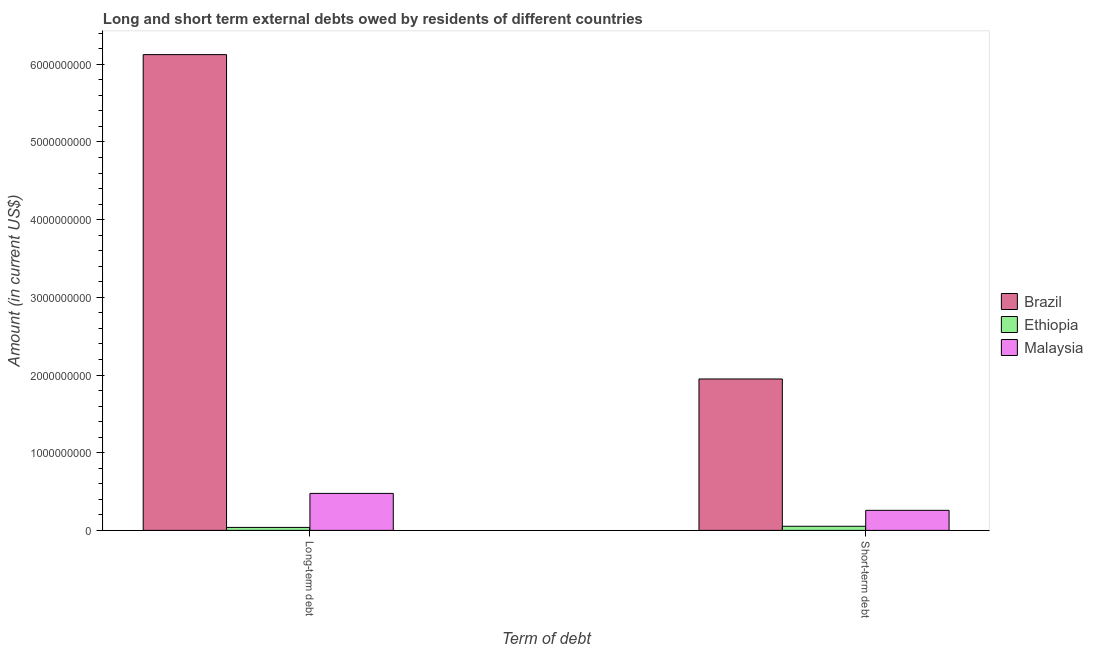How many groups of bars are there?
Offer a very short reply. 2. Are the number of bars on each tick of the X-axis equal?
Keep it short and to the point. Yes. How many bars are there on the 1st tick from the left?
Provide a short and direct response. 3. What is the label of the 2nd group of bars from the left?
Keep it short and to the point. Short-term debt. What is the short-term debts owed by residents in Ethiopia?
Make the answer very short. 5.30e+07. Across all countries, what is the maximum long-term debts owed by residents?
Your answer should be compact. 6.12e+09. Across all countries, what is the minimum long-term debts owed by residents?
Make the answer very short. 3.83e+07. In which country was the short-term debts owed by residents minimum?
Offer a very short reply. Ethiopia. What is the total short-term debts owed by residents in the graph?
Your answer should be very brief. 2.26e+09. What is the difference between the short-term debts owed by residents in Ethiopia and that in Malaysia?
Make the answer very short. -2.05e+08. What is the difference between the long-term debts owed by residents in Brazil and the short-term debts owed by residents in Malaysia?
Give a very brief answer. 5.87e+09. What is the average short-term debts owed by residents per country?
Keep it short and to the point. 7.53e+08. What is the difference between the long-term debts owed by residents and short-term debts owed by residents in Brazil?
Provide a short and direct response. 4.18e+09. What is the ratio of the short-term debts owed by residents in Malaysia to that in Brazil?
Make the answer very short. 0.13. In how many countries, is the short-term debts owed by residents greater than the average short-term debts owed by residents taken over all countries?
Offer a terse response. 1. What does the 2nd bar from the left in Short-term debt represents?
Offer a terse response. Ethiopia. What does the 1st bar from the right in Short-term debt represents?
Your response must be concise. Malaysia. How many bars are there?
Provide a succinct answer. 6. Are all the bars in the graph horizontal?
Keep it short and to the point. No. Does the graph contain any zero values?
Your answer should be very brief. No. Does the graph contain grids?
Keep it short and to the point. No. Where does the legend appear in the graph?
Your answer should be very brief. Center right. What is the title of the graph?
Ensure brevity in your answer.  Long and short term external debts owed by residents of different countries. Does "Lao PDR" appear as one of the legend labels in the graph?
Make the answer very short. No. What is the label or title of the X-axis?
Your answer should be compact. Term of debt. What is the label or title of the Y-axis?
Give a very brief answer. Amount (in current US$). What is the Amount (in current US$) in Brazil in Long-term debt?
Keep it short and to the point. 6.12e+09. What is the Amount (in current US$) of Ethiopia in Long-term debt?
Provide a short and direct response. 3.83e+07. What is the Amount (in current US$) in Malaysia in Long-term debt?
Provide a short and direct response. 4.76e+08. What is the Amount (in current US$) of Brazil in Short-term debt?
Provide a short and direct response. 1.95e+09. What is the Amount (in current US$) in Ethiopia in Short-term debt?
Make the answer very short. 5.30e+07. What is the Amount (in current US$) of Malaysia in Short-term debt?
Give a very brief answer. 2.58e+08. Across all Term of debt, what is the maximum Amount (in current US$) of Brazil?
Offer a very short reply. 6.12e+09. Across all Term of debt, what is the maximum Amount (in current US$) of Ethiopia?
Your answer should be compact. 5.30e+07. Across all Term of debt, what is the maximum Amount (in current US$) in Malaysia?
Provide a short and direct response. 4.76e+08. Across all Term of debt, what is the minimum Amount (in current US$) in Brazil?
Provide a succinct answer. 1.95e+09. Across all Term of debt, what is the minimum Amount (in current US$) in Ethiopia?
Offer a terse response. 3.83e+07. Across all Term of debt, what is the minimum Amount (in current US$) of Malaysia?
Offer a terse response. 2.58e+08. What is the total Amount (in current US$) of Brazil in the graph?
Your answer should be very brief. 8.07e+09. What is the total Amount (in current US$) of Ethiopia in the graph?
Make the answer very short. 9.13e+07. What is the total Amount (in current US$) of Malaysia in the graph?
Give a very brief answer. 7.34e+08. What is the difference between the Amount (in current US$) in Brazil in Long-term debt and that in Short-term debt?
Provide a succinct answer. 4.18e+09. What is the difference between the Amount (in current US$) of Ethiopia in Long-term debt and that in Short-term debt?
Make the answer very short. -1.47e+07. What is the difference between the Amount (in current US$) in Malaysia in Long-term debt and that in Short-term debt?
Keep it short and to the point. 2.18e+08. What is the difference between the Amount (in current US$) of Brazil in Long-term debt and the Amount (in current US$) of Ethiopia in Short-term debt?
Offer a very short reply. 6.07e+09. What is the difference between the Amount (in current US$) in Brazil in Long-term debt and the Amount (in current US$) in Malaysia in Short-term debt?
Ensure brevity in your answer.  5.87e+09. What is the difference between the Amount (in current US$) in Ethiopia in Long-term debt and the Amount (in current US$) in Malaysia in Short-term debt?
Make the answer very short. -2.20e+08. What is the average Amount (in current US$) of Brazil per Term of debt?
Ensure brevity in your answer.  4.04e+09. What is the average Amount (in current US$) of Ethiopia per Term of debt?
Your response must be concise. 4.56e+07. What is the average Amount (in current US$) in Malaysia per Term of debt?
Keep it short and to the point. 3.67e+08. What is the difference between the Amount (in current US$) in Brazil and Amount (in current US$) in Ethiopia in Long-term debt?
Give a very brief answer. 6.09e+09. What is the difference between the Amount (in current US$) in Brazil and Amount (in current US$) in Malaysia in Long-term debt?
Make the answer very short. 5.65e+09. What is the difference between the Amount (in current US$) in Ethiopia and Amount (in current US$) in Malaysia in Long-term debt?
Offer a terse response. -4.38e+08. What is the difference between the Amount (in current US$) of Brazil and Amount (in current US$) of Ethiopia in Short-term debt?
Offer a terse response. 1.90e+09. What is the difference between the Amount (in current US$) of Brazil and Amount (in current US$) of Malaysia in Short-term debt?
Make the answer very short. 1.69e+09. What is the difference between the Amount (in current US$) in Ethiopia and Amount (in current US$) in Malaysia in Short-term debt?
Provide a succinct answer. -2.05e+08. What is the ratio of the Amount (in current US$) of Brazil in Long-term debt to that in Short-term debt?
Your answer should be compact. 3.14. What is the ratio of the Amount (in current US$) in Ethiopia in Long-term debt to that in Short-term debt?
Offer a very short reply. 0.72. What is the ratio of the Amount (in current US$) in Malaysia in Long-term debt to that in Short-term debt?
Your answer should be compact. 1.85. What is the difference between the highest and the second highest Amount (in current US$) of Brazil?
Keep it short and to the point. 4.18e+09. What is the difference between the highest and the second highest Amount (in current US$) of Ethiopia?
Provide a short and direct response. 1.47e+07. What is the difference between the highest and the second highest Amount (in current US$) in Malaysia?
Offer a very short reply. 2.18e+08. What is the difference between the highest and the lowest Amount (in current US$) of Brazil?
Give a very brief answer. 4.18e+09. What is the difference between the highest and the lowest Amount (in current US$) in Ethiopia?
Provide a succinct answer. 1.47e+07. What is the difference between the highest and the lowest Amount (in current US$) of Malaysia?
Give a very brief answer. 2.18e+08. 